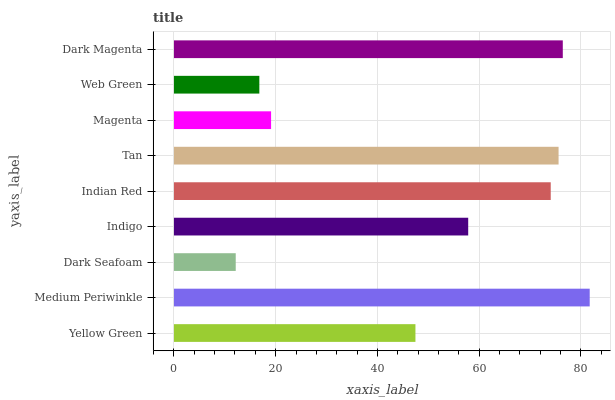Is Dark Seafoam the minimum?
Answer yes or no. Yes. Is Medium Periwinkle the maximum?
Answer yes or no. Yes. Is Medium Periwinkle the minimum?
Answer yes or no. No. Is Dark Seafoam the maximum?
Answer yes or no. No. Is Medium Periwinkle greater than Dark Seafoam?
Answer yes or no. Yes. Is Dark Seafoam less than Medium Periwinkle?
Answer yes or no. Yes. Is Dark Seafoam greater than Medium Periwinkle?
Answer yes or no. No. Is Medium Periwinkle less than Dark Seafoam?
Answer yes or no. No. Is Indigo the high median?
Answer yes or no. Yes. Is Indigo the low median?
Answer yes or no. Yes. Is Indian Red the high median?
Answer yes or no. No. Is Indian Red the low median?
Answer yes or no. No. 